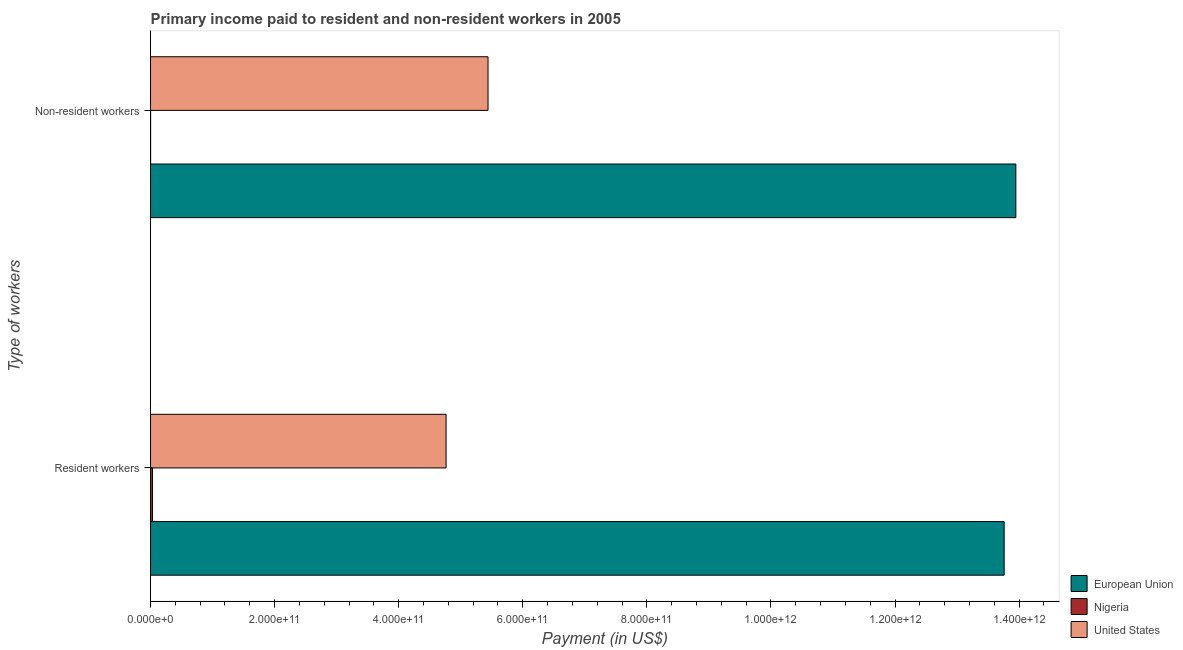How many different coloured bars are there?
Keep it short and to the point. 3. How many groups of bars are there?
Offer a very short reply. 2. Are the number of bars per tick equal to the number of legend labels?
Provide a succinct answer. Yes. How many bars are there on the 2nd tick from the top?
Your response must be concise. 3. How many bars are there on the 2nd tick from the bottom?
Provide a short and direct response. 3. What is the label of the 1st group of bars from the top?
Your response must be concise. Non-resident workers. What is the payment made to non-resident workers in Nigeria?
Make the answer very short. 1.55e+08. Across all countries, what is the maximum payment made to resident workers?
Make the answer very short. 1.38e+12. Across all countries, what is the minimum payment made to resident workers?
Provide a short and direct response. 3.15e+09. In which country was the payment made to resident workers minimum?
Your answer should be very brief. Nigeria. What is the total payment made to resident workers in the graph?
Provide a short and direct response. 1.86e+12. What is the difference between the payment made to non-resident workers in United States and that in European Union?
Make the answer very short. -8.51e+11. What is the difference between the payment made to resident workers in Nigeria and the payment made to non-resident workers in United States?
Keep it short and to the point. -5.41e+11. What is the average payment made to resident workers per country?
Your answer should be very brief. 6.18e+11. What is the difference between the payment made to non-resident workers and payment made to resident workers in United States?
Keep it short and to the point. 6.76e+1. In how many countries, is the payment made to resident workers greater than 760000000000 US$?
Your answer should be very brief. 1. What is the ratio of the payment made to non-resident workers in Nigeria to that in United States?
Give a very brief answer. 0. Is the payment made to non-resident workers in European Union less than that in United States?
Your answer should be very brief. No. In how many countries, is the payment made to non-resident workers greater than the average payment made to non-resident workers taken over all countries?
Keep it short and to the point. 1. What does the 1st bar from the top in Non-resident workers represents?
Your response must be concise. United States. What does the 2nd bar from the bottom in Resident workers represents?
Offer a very short reply. Nigeria. How many bars are there?
Give a very brief answer. 6. Are all the bars in the graph horizontal?
Your response must be concise. Yes. How many countries are there in the graph?
Provide a succinct answer. 3. What is the difference between two consecutive major ticks on the X-axis?
Your response must be concise. 2.00e+11. Are the values on the major ticks of X-axis written in scientific E-notation?
Keep it short and to the point. Yes. Where does the legend appear in the graph?
Provide a succinct answer. Bottom right. How are the legend labels stacked?
Provide a short and direct response. Vertical. What is the title of the graph?
Your answer should be very brief. Primary income paid to resident and non-resident workers in 2005. Does "Macedonia" appear as one of the legend labels in the graph?
Ensure brevity in your answer.  No. What is the label or title of the X-axis?
Your answer should be compact. Payment (in US$). What is the label or title of the Y-axis?
Offer a terse response. Type of workers. What is the Payment (in US$) in European Union in Resident workers?
Offer a very short reply. 1.38e+12. What is the Payment (in US$) in Nigeria in Resident workers?
Offer a terse response. 3.15e+09. What is the Payment (in US$) in United States in Resident workers?
Your answer should be compact. 4.76e+11. What is the Payment (in US$) of European Union in Non-resident workers?
Offer a terse response. 1.39e+12. What is the Payment (in US$) of Nigeria in Non-resident workers?
Give a very brief answer. 1.55e+08. What is the Payment (in US$) of United States in Non-resident workers?
Ensure brevity in your answer.  5.44e+11. Across all Type of workers, what is the maximum Payment (in US$) of European Union?
Give a very brief answer. 1.39e+12. Across all Type of workers, what is the maximum Payment (in US$) in Nigeria?
Give a very brief answer. 3.15e+09. Across all Type of workers, what is the maximum Payment (in US$) in United States?
Ensure brevity in your answer.  5.44e+11. Across all Type of workers, what is the minimum Payment (in US$) of European Union?
Ensure brevity in your answer.  1.38e+12. Across all Type of workers, what is the minimum Payment (in US$) of Nigeria?
Offer a terse response. 1.55e+08. Across all Type of workers, what is the minimum Payment (in US$) in United States?
Offer a terse response. 4.76e+11. What is the total Payment (in US$) of European Union in the graph?
Provide a succinct answer. 2.77e+12. What is the total Payment (in US$) in Nigeria in the graph?
Keep it short and to the point. 3.30e+09. What is the total Payment (in US$) in United States in the graph?
Your response must be concise. 1.02e+12. What is the difference between the Payment (in US$) of European Union in Resident workers and that in Non-resident workers?
Provide a succinct answer. -1.88e+1. What is the difference between the Payment (in US$) of Nigeria in Resident workers and that in Non-resident workers?
Keep it short and to the point. 2.99e+09. What is the difference between the Payment (in US$) in United States in Resident workers and that in Non-resident workers?
Your answer should be very brief. -6.76e+1. What is the difference between the Payment (in US$) of European Union in Resident workers and the Payment (in US$) of Nigeria in Non-resident workers?
Provide a short and direct response. 1.38e+12. What is the difference between the Payment (in US$) of European Union in Resident workers and the Payment (in US$) of United States in Non-resident workers?
Your answer should be very brief. 8.32e+11. What is the difference between the Payment (in US$) in Nigeria in Resident workers and the Payment (in US$) in United States in Non-resident workers?
Make the answer very short. -5.41e+11. What is the average Payment (in US$) of European Union per Type of workers?
Your answer should be very brief. 1.39e+12. What is the average Payment (in US$) in Nigeria per Type of workers?
Provide a succinct answer. 1.65e+09. What is the average Payment (in US$) in United States per Type of workers?
Offer a very short reply. 5.10e+11. What is the difference between the Payment (in US$) in European Union and Payment (in US$) in Nigeria in Resident workers?
Your answer should be compact. 1.37e+12. What is the difference between the Payment (in US$) of European Union and Payment (in US$) of United States in Resident workers?
Keep it short and to the point. 9.00e+11. What is the difference between the Payment (in US$) in Nigeria and Payment (in US$) in United States in Resident workers?
Offer a terse response. -4.73e+11. What is the difference between the Payment (in US$) in European Union and Payment (in US$) in Nigeria in Non-resident workers?
Your answer should be compact. 1.39e+12. What is the difference between the Payment (in US$) in European Union and Payment (in US$) in United States in Non-resident workers?
Your response must be concise. 8.51e+11. What is the difference between the Payment (in US$) of Nigeria and Payment (in US$) of United States in Non-resident workers?
Offer a very short reply. -5.44e+11. What is the ratio of the Payment (in US$) in European Union in Resident workers to that in Non-resident workers?
Ensure brevity in your answer.  0.99. What is the ratio of the Payment (in US$) in Nigeria in Resident workers to that in Non-resident workers?
Your response must be concise. 20.28. What is the ratio of the Payment (in US$) in United States in Resident workers to that in Non-resident workers?
Give a very brief answer. 0.88. What is the difference between the highest and the second highest Payment (in US$) in European Union?
Ensure brevity in your answer.  1.88e+1. What is the difference between the highest and the second highest Payment (in US$) in Nigeria?
Offer a terse response. 2.99e+09. What is the difference between the highest and the second highest Payment (in US$) in United States?
Keep it short and to the point. 6.76e+1. What is the difference between the highest and the lowest Payment (in US$) in European Union?
Your answer should be compact. 1.88e+1. What is the difference between the highest and the lowest Payment (in US$) in Nigeria?
Your answer should be compact. 2.99e+09. What is the difference between the highest and the lowest Payment (in US$) in United States?
Provide a succinct answer. 6.76e+1. 